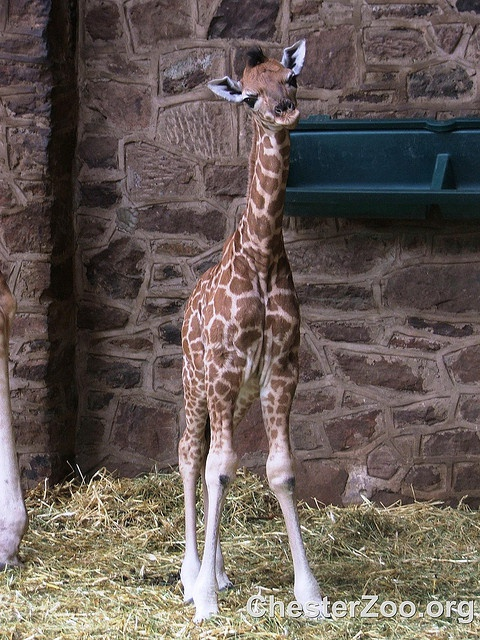Describe the objects in this image and their specific colors. I can see a giraffe in brown, gray, lavender, and darkgray tones in this image. 